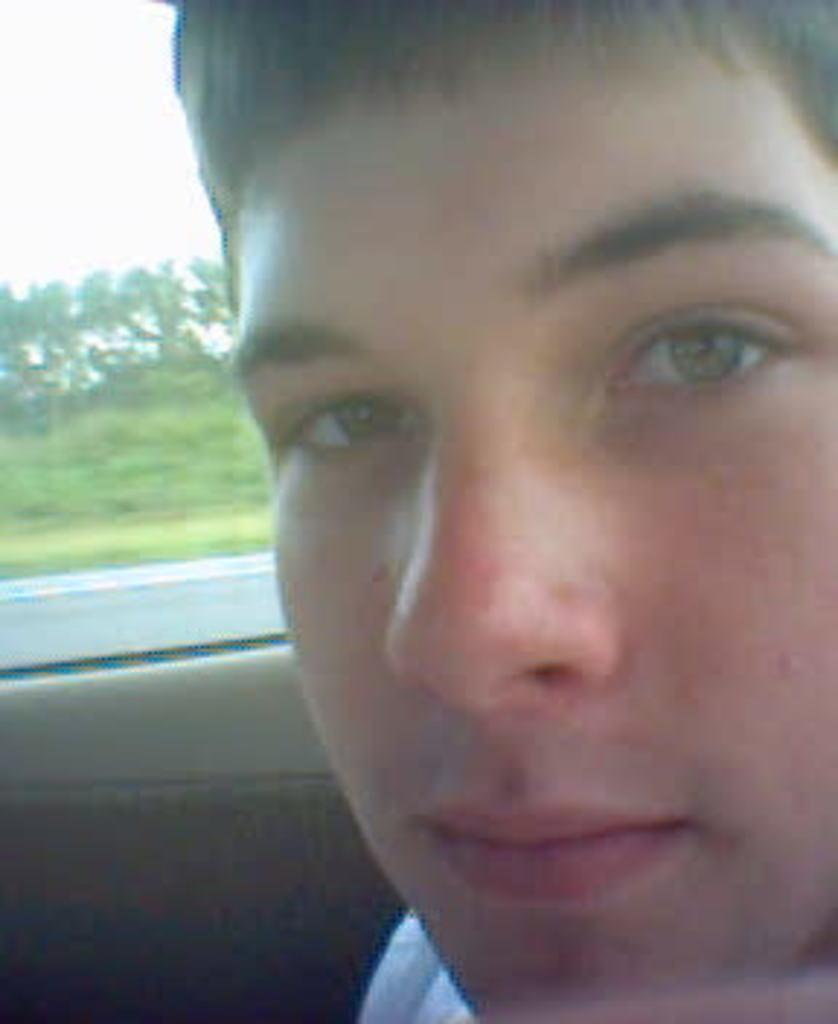Who is present in the image? There is a man in the image. What is the man's location in the image? The man appears to be inside a vehicle. What can be seen through the window in the image? Trees and grass are visible through the window. What type of fruit is hanging from the trees visible through the window? There is no fruit visible in the image; only trees and grass can be seen through the window. 